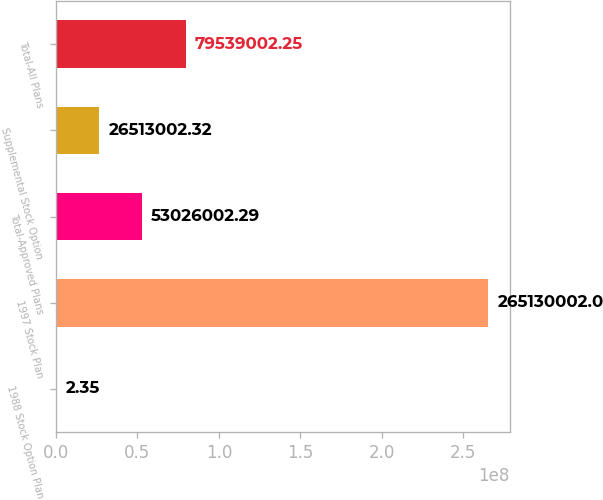<chart> <loc_0><loc_0><loc_500><loc_500><bar_chart><fcel>1988 Stock Option Plan<fcel>1997 Stock Plan<fcel>Total-Approved Plans<fcel>Supplemental Stock Option<fcel>Total-All Plans<nl><fcel>2.35<fcel>2.6513e+08<fcel>5.3026e+07<fcel>2.6513e+07<fcel>7.9539e+07<nl></chart> 